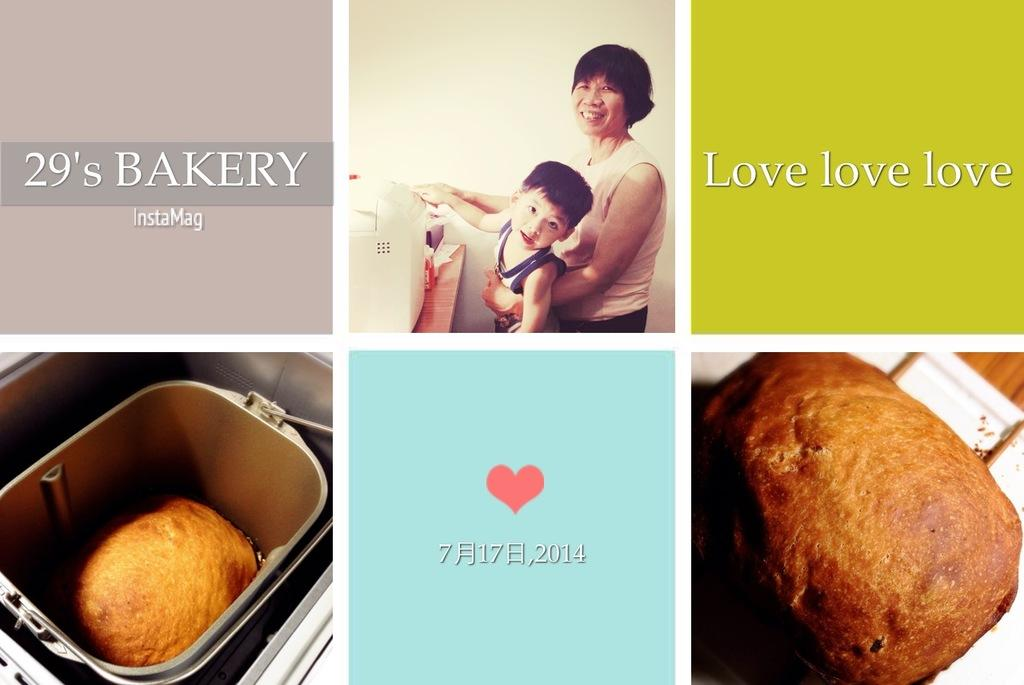<image>
Describe the image concisely. a graphic made of squares with food advertising 29's bakery 